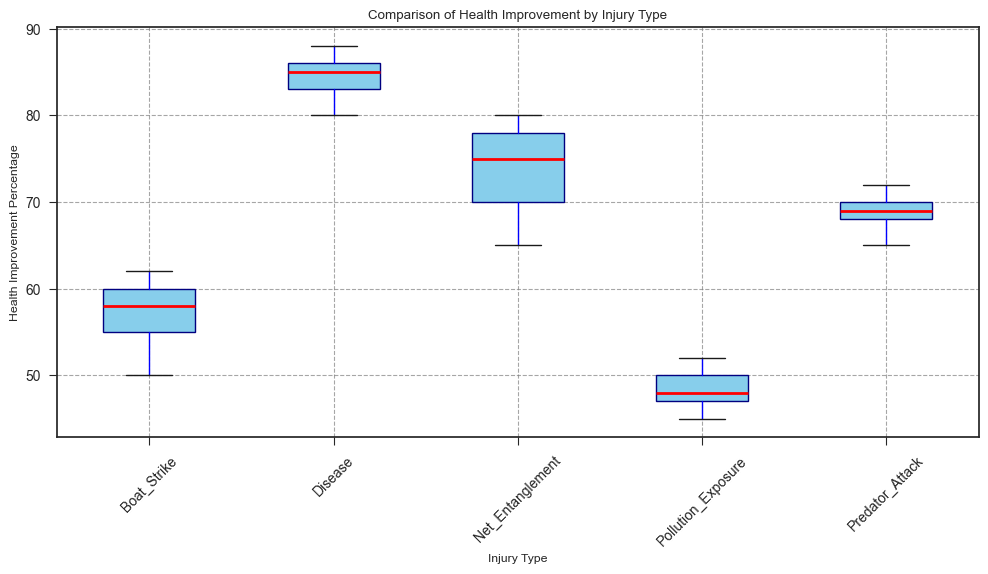What is the median health improvement percentage for animals affected by net entanglement? Look for the red line (median) within the box representing the Net Entanglement group.
Answer: 75 Which injury type has the highest median health improvement percentage? Compare the medians (red lines) across all the boxes. The highest median will be the tallest red line.
Answer: Disease What is the range of health improvement percentages for the Boat Strike group? Observing the boxplot for Boat Strike, the range is from the bottom of the whisker to the top of the whisker.
Answer: 50 to 62 How does the interquartile range (IQR) for Pollution Exposure compare to that of Net Entanglement? The IQR is the range between the bottom and top of the box. Compare the height of the boxes for Pollution Exposure and Net Entanglement.
Answer: Pollution Exposure: 45 to 52, Net Entanglement: 65 to 78 What is the difference between the median health improvement percentages of Boat Strike and Predator Attack? Subtract the median of Boat Strike by the median of Predator Attack by finding the corresponding red lines.
Answer: Predator Attack (69) - Boat Strike (58) = 11 Which injury type shows the highest variability in health improvement? Look at the distance between the top and bottom whiskers for each injury type. The largest distance indicates the highest variability.
Answer: Net Entanglement Are there any outliers in the health improvement percentages for any group? Check for any points that lie outside the whiskers of the box plots, often marked with small circles or dots.
Answer: No Between which two injury types is the difference in median health improvement percentages the smallest? Compare the position of the red lines (medians) across all groups.
Answer: Predator Attack and Net Entanglement What can be said about the central tendency of health improvement for animals affected by disease compared to those affected by pollution exposure? Compare the median (red line) and the spread of the boxes for Disease and Pollution Exposure.
Answer: Disease has a higher median and a more consistent health improvement 